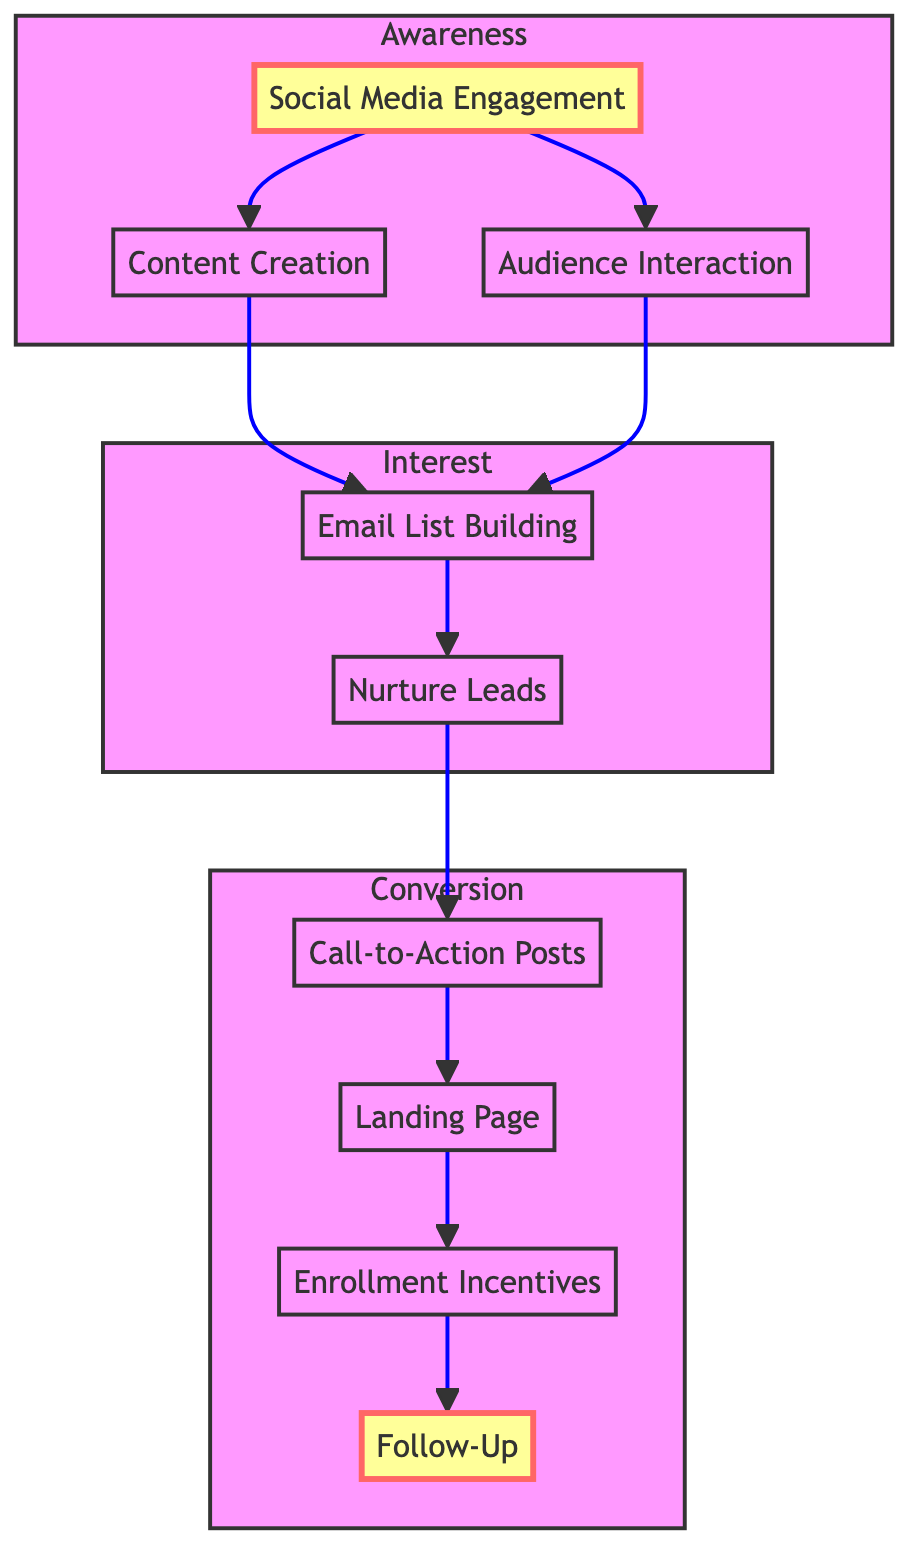What's the first step in the student enrollment funnel? The first step is "Social Media Engagement," which is indicated at the beginning of the flowchart. It starts the funnel process by engaging with the audience.
Answer: Social Media Engagement How many nodes are in the "Interest" subgraph? The "Interest" subgraph consists of three nodes: "Email List Building," "Nurture Leads." Therefore, the total number of nodes is counted physically in the diagram.
Answer: 2 What type of interaction is represented by the "Call-to-Action Posts"? The "Call-to-Action Posts" are specifically designed to drive enrollment by encouraging direct actions from the audience. This designates their purpose in the enrollment funnel clearly.
Answer: Drive enrollment Which node follows "Nurture Leads" in the funnel? The next node after "Nurture Leads" is "Call-to-Action Posts," as depicted in the diagram. This is the direct progression from nurturing leads to encouraging action.
Answer: Call-to-Action Posts What is the primary function of "Email List Building"? "Email List Building" functions to collect emails through various means such as sign-ups and incentives, serving as a foundational step in capturing potential student information.
Answer: Collecting emails How many steps are in the "Conversion" phase? The "Conversion" phase contains four steps: "Call-to-Action Posts," "Landing Page," "Enrollment Incentives," and "Follow-Up," which collectively make up this phase in the funnel.
Answer: 4 What is the relationship between "Audience Interaction" and "Email List Building"? "Audience Interaction" contributes to "Email List Building" as engagement with the audience helps prompt email sign-ups and interest in further communication. This relationship is represented by a direct connection in the diagram.
Answer: Contributes What incentivizes students to enroll? "Enrollment Incentives," such as discount codes and early-bird specials, are specifically designed to encourage students to finalize their enrollment decision.
Answer: Enrollment incentives What color represents the "Awareness" subgraph in the diagram? The "Awareness" subgraph is filled with a light blue color, as indicated by the style associated with that section of the diagram.
Answer: Light blue 